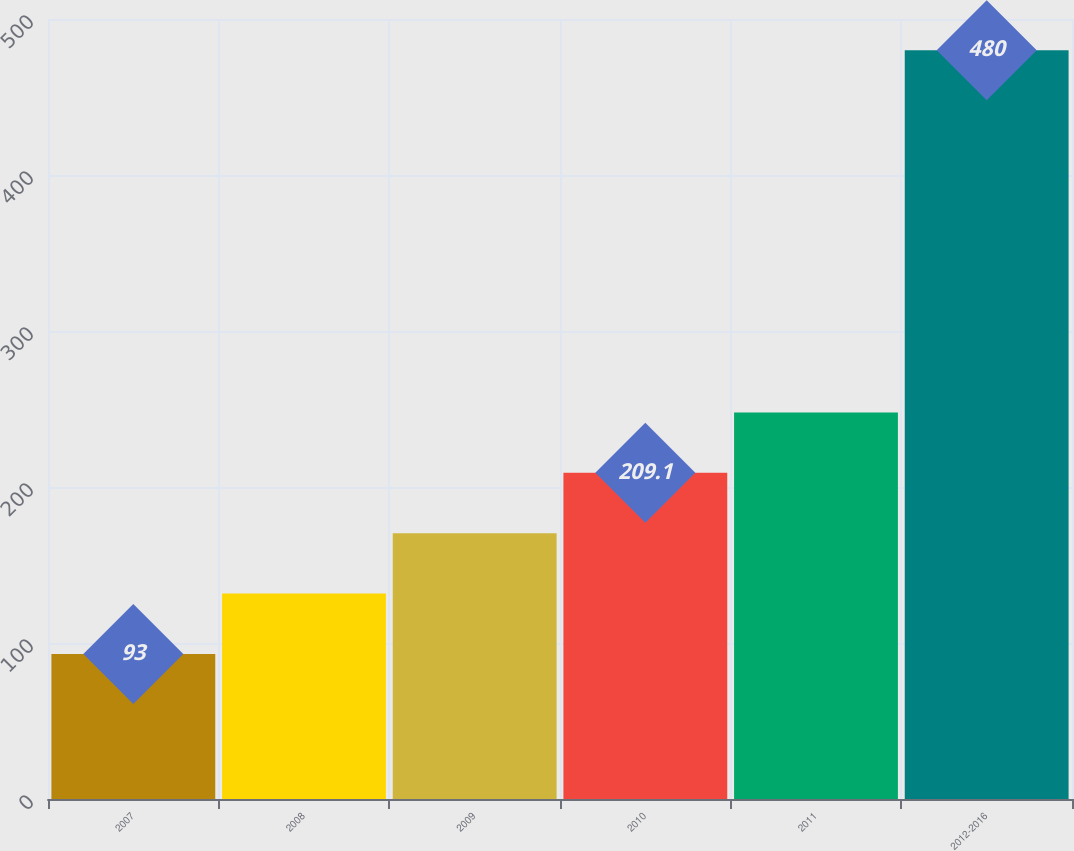Convert chart to OTSL. <chart><loc_0><loc_0><loc_500><loc_500><bar_chart><fcel>2007<fcel>2008<fcel>2009<fcel>2010<fcel>2011<fcel>2012-2016<nl><fcel>93<fcel>131.7<fcel>170.4<fcel>209.1<fcel>247.8<fcel>480<nl></chart> 